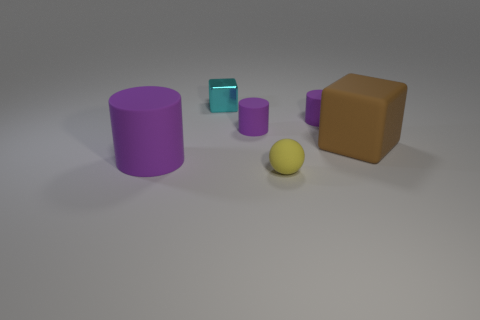How many purple cylinders must be subtracted to get 1 purple cylinders? 2 Subtract all tiny cylinders. How many cylinders are left? 1 Add 3 purple metallic cylinders. How many objects exist? 9 Subtract all spheres. How many objects are left? 5 Subtract 2 cylinders. How many cylinders are left? 1 Subtract all yellow cubes. Subtract all brown cylinders. How many cubes are left? 2 Subtract all small matte things. Subtract all spheres. How many objects are left? 2 Add 3 small balls. How many small balls are left? 4 Add 2 large purple cubes. How many large purple cubes exist? 2 Subtract 0 red balls. How many objects are left? 6 